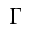Convert formula to latex. <formula><loc_0><loc_0><loc_500><loc_500>\Gamma</formula> 